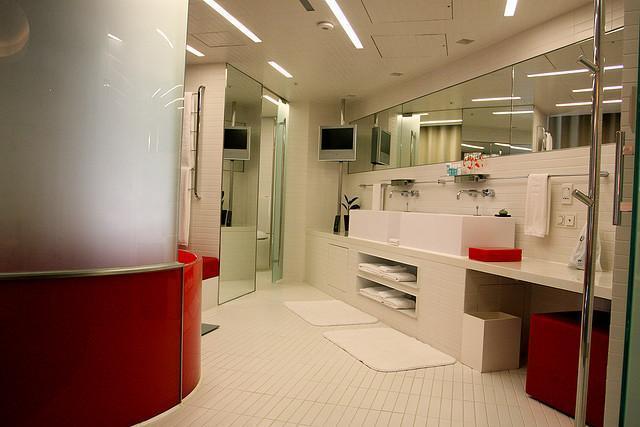How many rugs are on the floor?
Give a very brief answer. 2. 